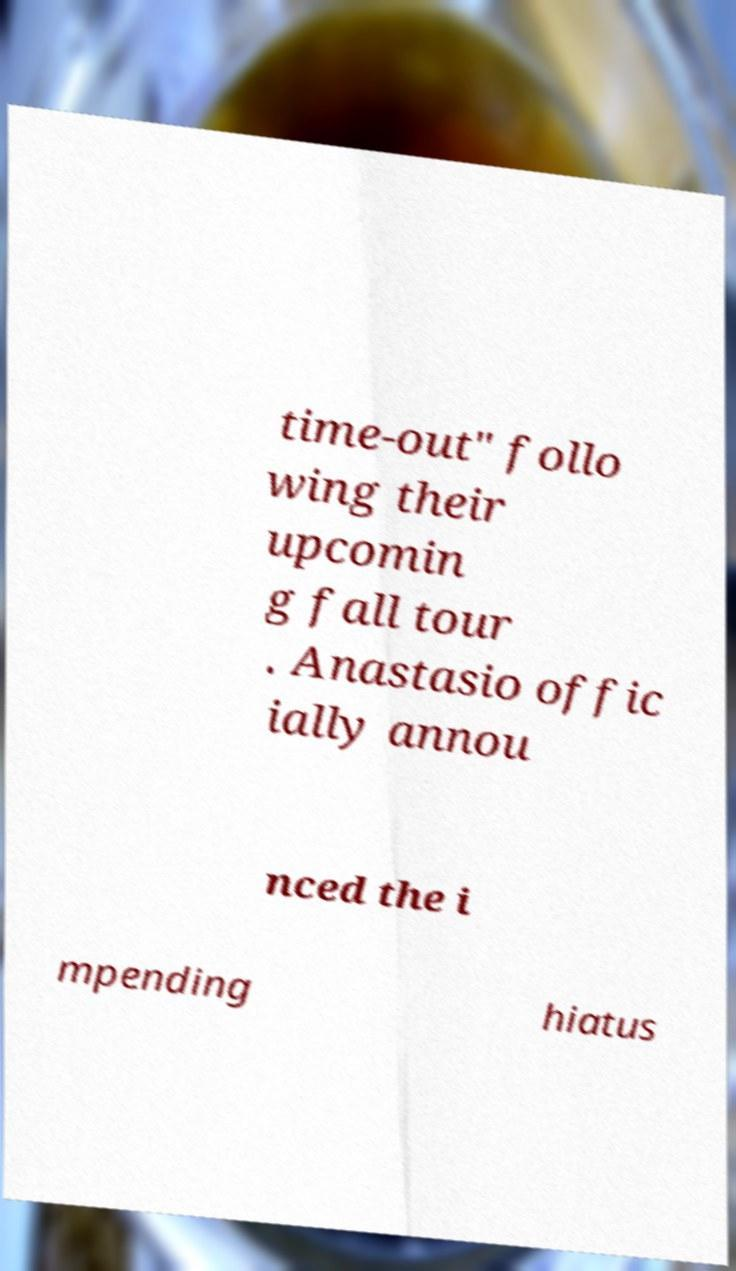I need the written content from this picture converted into text. Can you do that? time-out" follo wing their upcomin g fall tour . Anastasio offic ially annou nced the i mpending hiatus 